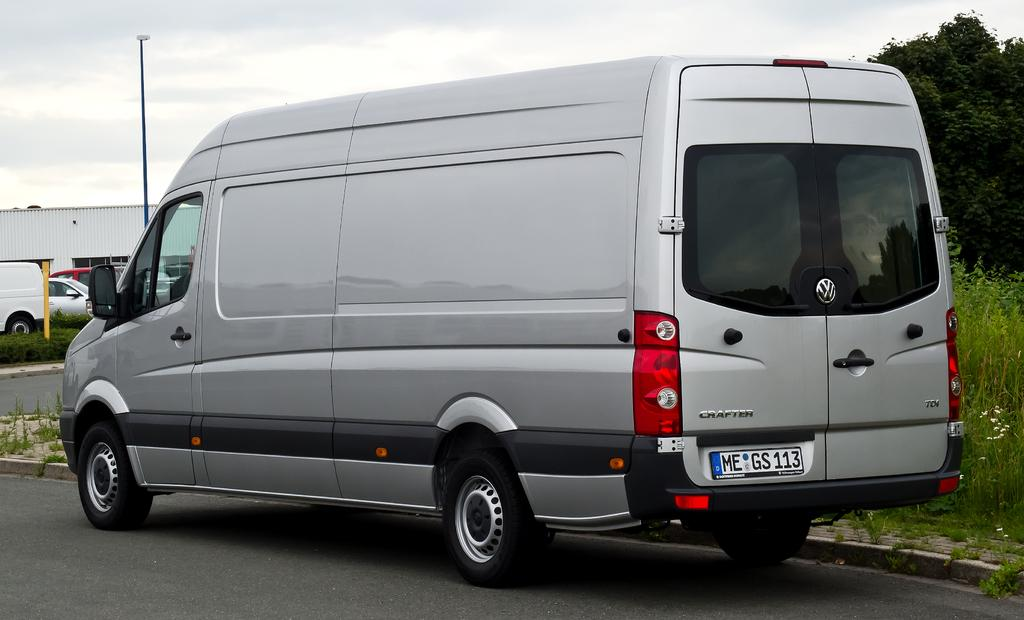Provide a one-sentence caption for the provided image. A silver Volkswagon van is stopped on the side of the street near wildflowers. 